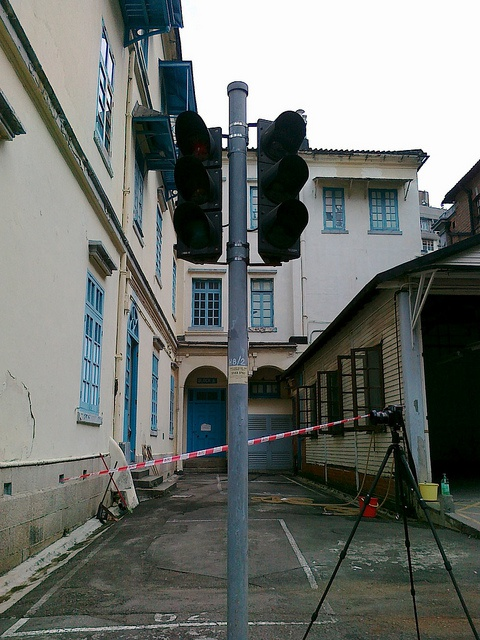Describe the objects in this image and their specific colors. I can see traffic light in black, darkgray, gray, and white tones and traffic light in black, gray, navy, and blue tones in this image. 